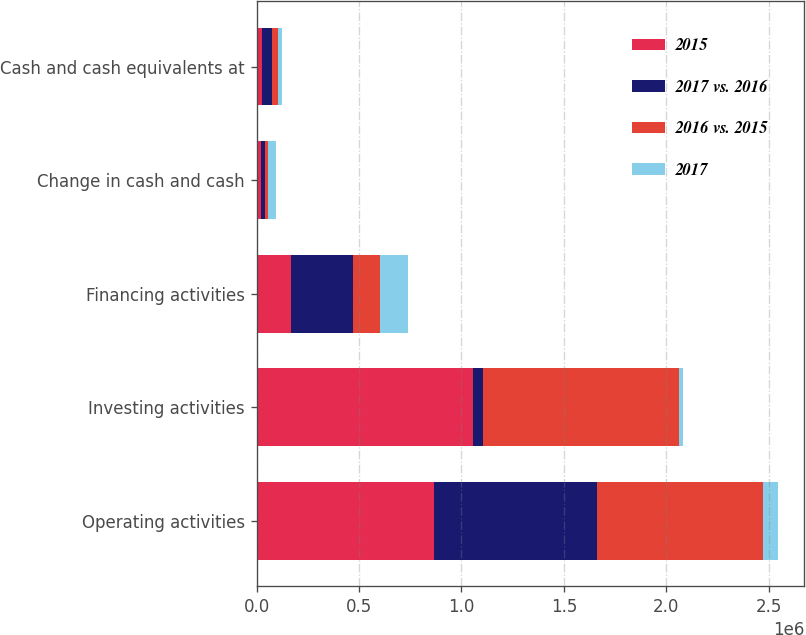Convert chart to OTSL. <chart><loc_0><loc_0><loc_500><loc_500><stacked_bar_chart><ecel><fcel>Operating activities<fcel>Investing activities<fcel>Financing activities<fcel>Change in cash and cash<fcel>Cash and cash equivalents at<nl><fcel>2015<fcel>867090<fcel>1.05631e+06<fcel>168091<fcel>21125<fcel>26409<nl><fcel>2017 vs. 2016<fcel>794990<fcel>47534<fcel>303623<fcel>18881<fcel>47534<nl><fcel>2016 vs. 2015<fcel>811914<fcel>956602<fcel>131083<fcel>13605<fcel>28653<nl><fcel>2017<fcel>72100<fcel>23426<fcel>135532<fcel>40006<fcel>21125<nl></chart> 